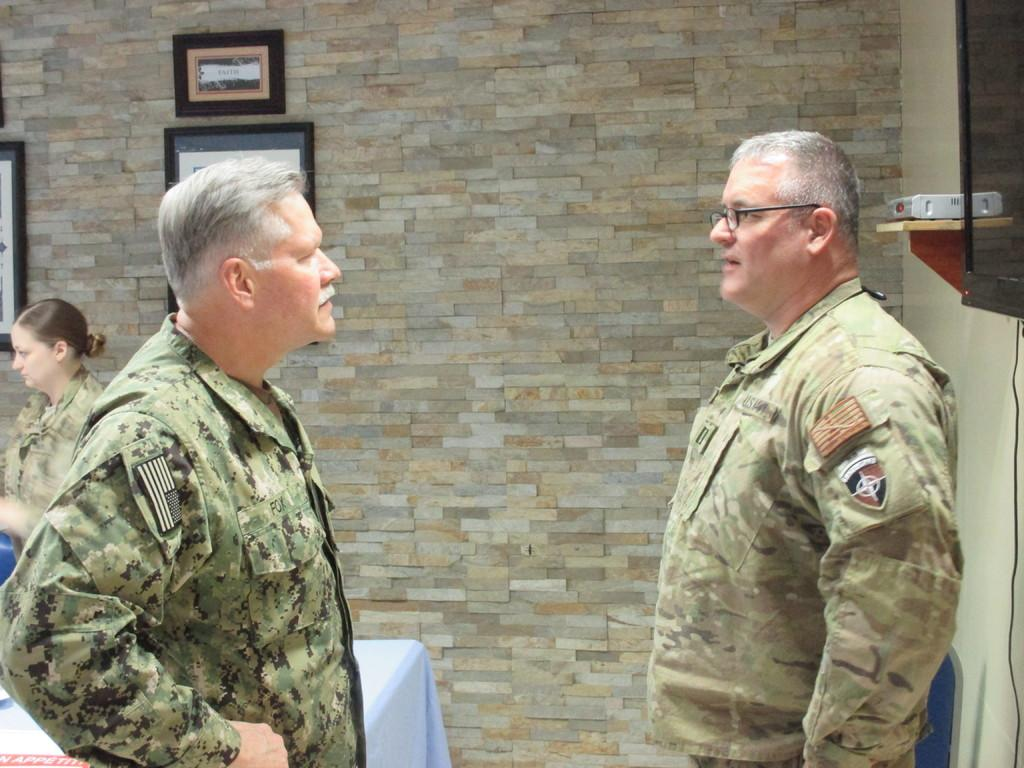How many people are present in the image? There are three people in the image: two men and one woman. Can you describe the woman's position in the image? The woman is standing on the left side of the image. What can be seen in the background of the image? There is a wall in the background of the image, and photos are displayed on the wall. What type of patch is being sewn onto the man's shirt in the image? There is no patch being sewn onto anyone's shirt in the image. Can you describe the ship that is sailing in the background of the image? There is no ship present in the image; it features two men, a woman, and a wall with photos in the background. 